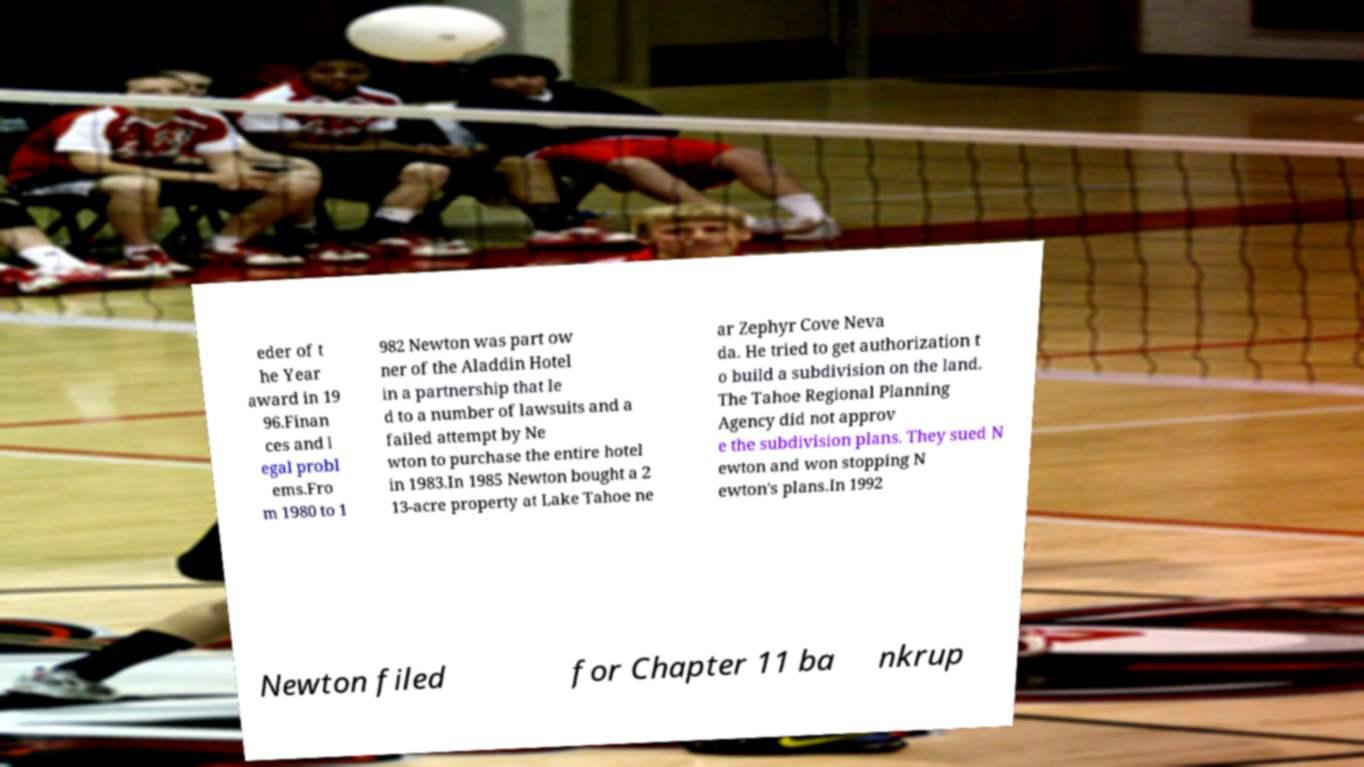Please read and relay the text visible in this image. What does it say? eder of t he Year award in 19 96.Finan ces and l egal probl ems.Fro m 1980 to 1 982 Newton was part ow ner of the Aladdin Hotel in a partnership that le d to a number of lawsuits and a failed attempt by Ne wton to purchase the entire hotel in 1983.In 1985 Newton bought a 2 13-acre property at Lake Tahoe ne ar Zephyr Cove Neva da. He tried to get authorization t o build a subdivision on the land. The Tahoe Regional Planning Agency did not approv e the subdivision plans. They sued N ewton and won stopping N ewton's plans.In 1992 Newton filed for Chapter 11 ba nkrup 